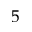Convert formula to latex. <formula><loc_0><loc_0><loc_500><loc_500>5</formula> 